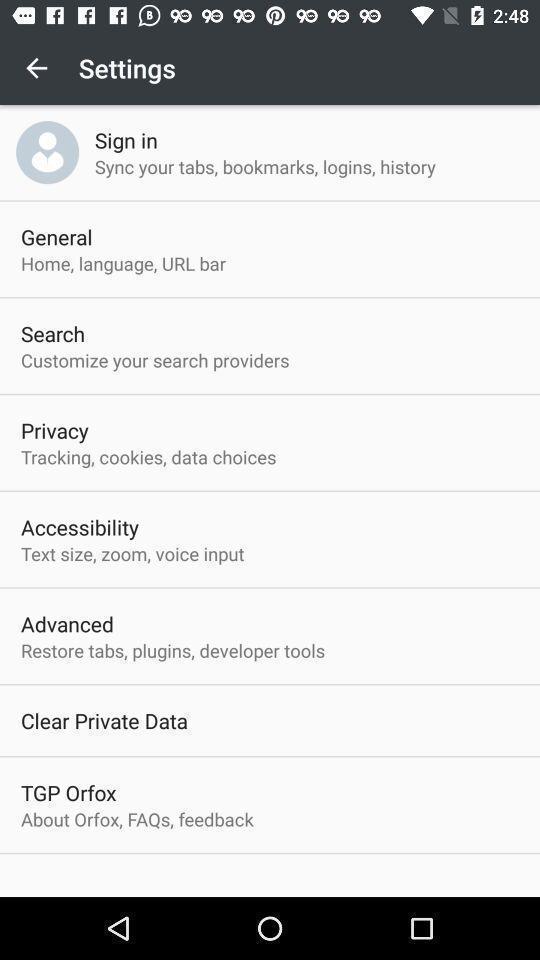Provide a description of this screenshot. Settings page displaying. 